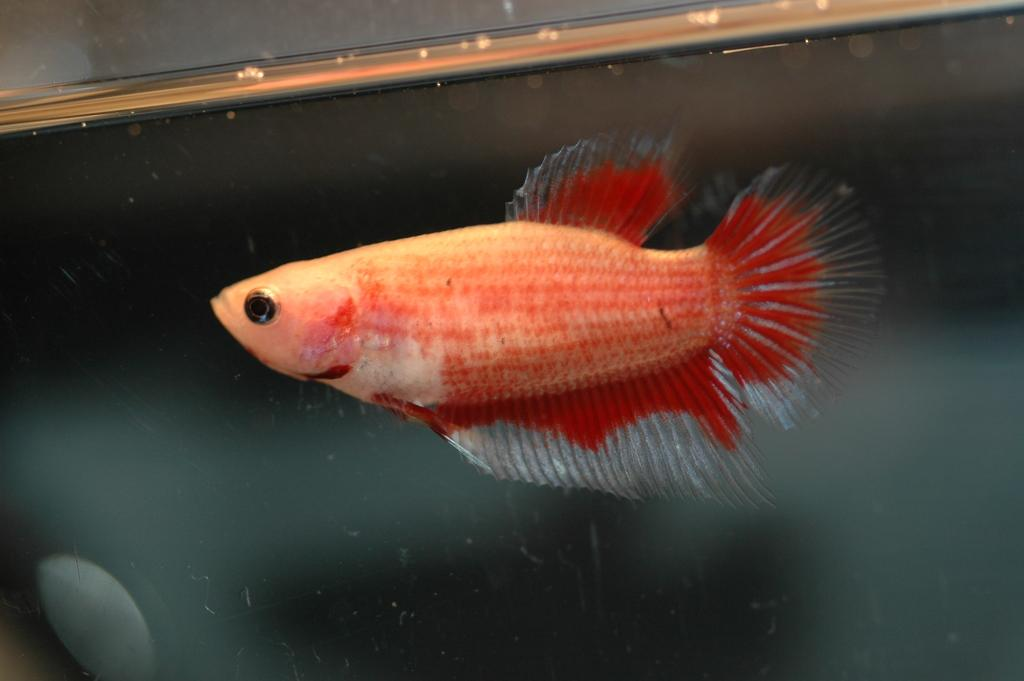What type of animal is in the image? There is a fish in the image. Where is the fish located? The fish is in an aquarium. What color is the fish? The fish is orange in color. What is the purpose of the legs in the image? There are no legs present in the image, as the subject is a fish in an aquarium. 